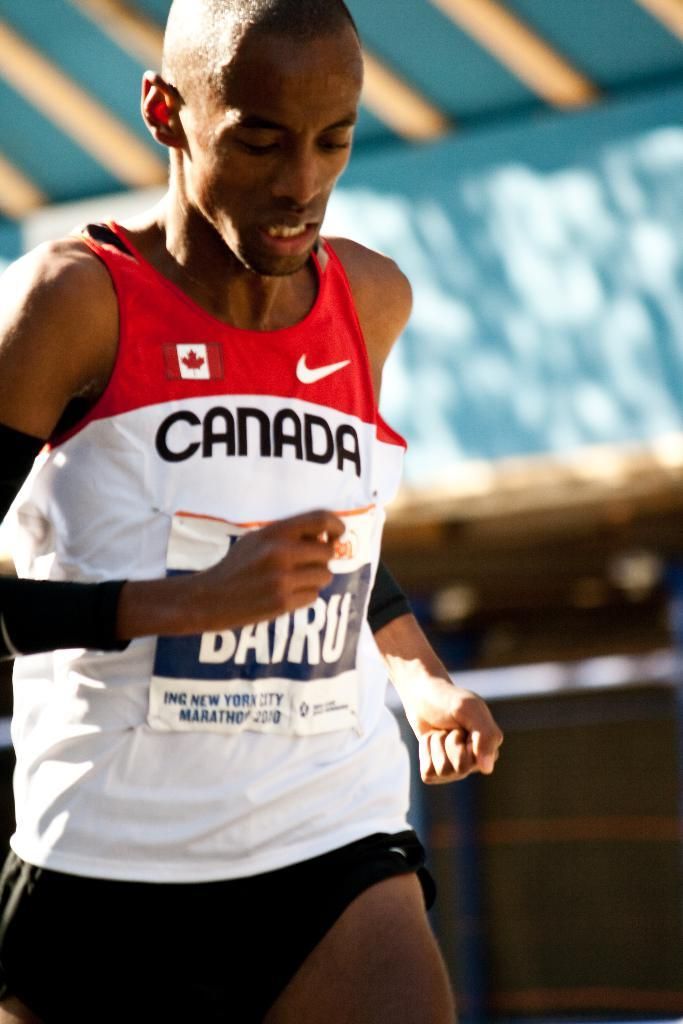<image>
Describe the image concisely. A man in a Canada shirt looks down as he runs. 